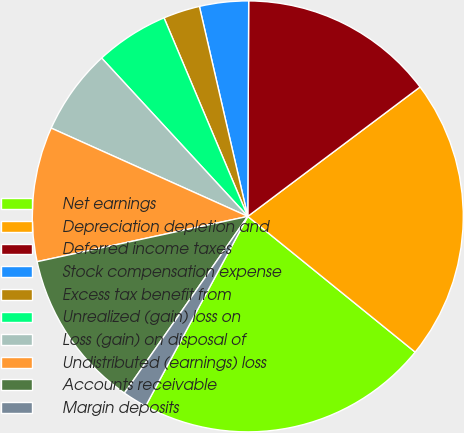Convert chart. <chart><loc_0><loc_0><loc_500><loc_500><pie_chart><fcel>Net earnings<fcel>Depreciation depletion and<fcel>Deferred income taxes<fcel>Stock compensation expense<fcel>Excess tax benefit from<fcel>Unrealized (gain) loss on<fcel>Loss (gain) on disposal of<fcel>Undistributed (earnings) loss<fcel>Accounts receivable<fcel>Margin deposits<nl><fcel>22.02%<fcel>21.1%<fcel>14.68%<fcel>3.67%<fcel>2.75%<fcel>5.51%<fcel>6.42%<fcel>10.09%<fcel>11.93%<fcel>1.84%<nl></chart> 